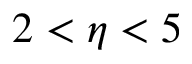<formula> <loc_0><loc_0><loc_500><loc_500>2 < \eta < 5</formula> 